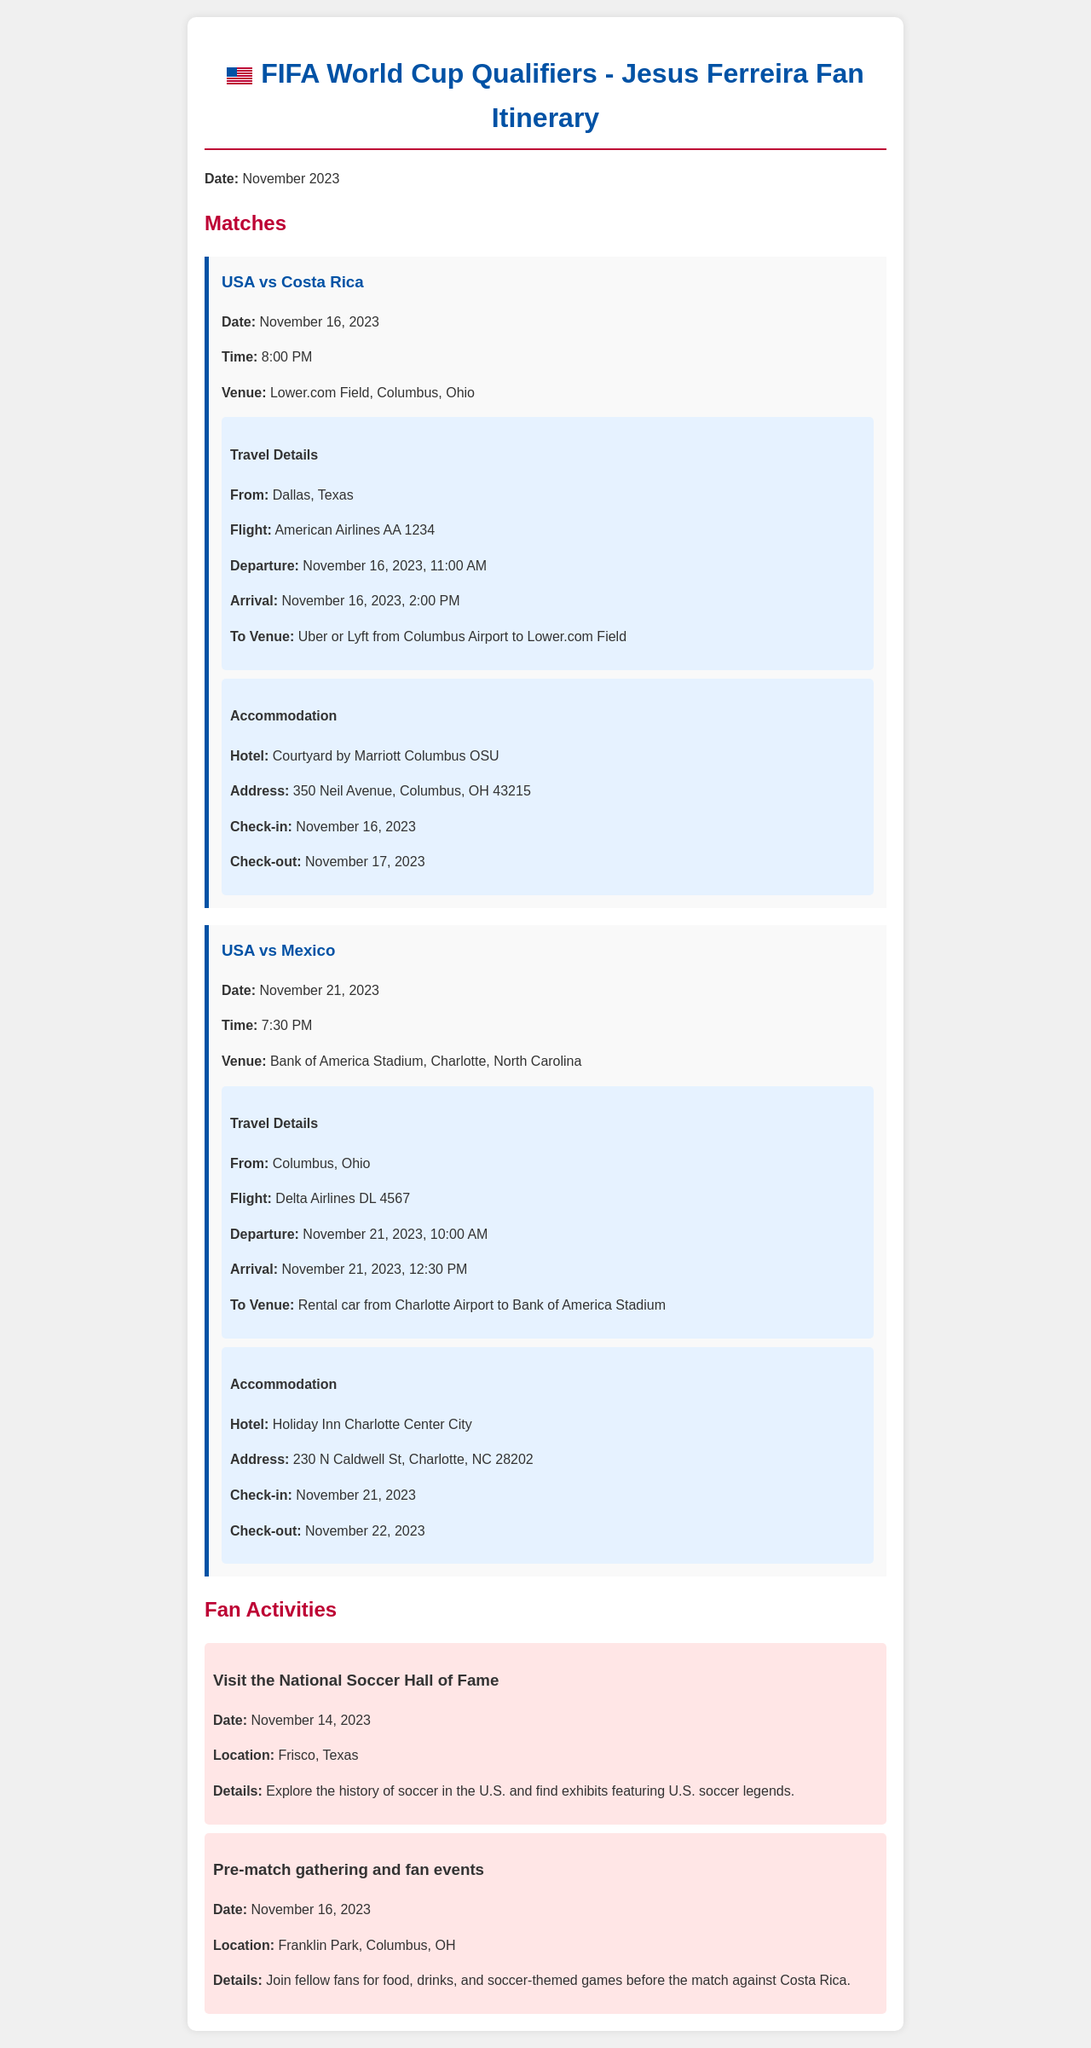What is the date of the match against Costa Rica? The match against Costa Rica is scheduled for November 16, 2023.
Answer: November 16, 2023 What time does the USA vs Mexico match start? The USA vs Mexico match is set to start at 7:30 PM.
Answer: 7:30 PM What is the venue for the match against Costa Rica? The venue for the match against Costa Rica is Lower.com Field, Columbus, Ohio.
Answer: Lower.com Field, Columbus, Ohio Where is the National Soccer Hall of Fame located? The National Soccer Hall of Fame is located in Frisco, Texas.
Answer: Frisco, Texas What is the flight number for the match against Costa Rica? The flight number from Dallas to Columbus for the match is American Airlines AA 1234.
Answer: American Airlines AA 1234 What type of transportation will be taken from Columbus Airport to the venue? The transportation from Columbus Airport to the venue will be Uber or Lyft.
Answer: Uber or Lyft What is the check-out date for the hotel in Charlotte? The check-out date at the Holiday Inn Charlotte Center City is November 22, 2023.
Answer: November 22, 2023 On what date will the pre-match gathering take place? The pre-match gathering will take place on November 16, 2023.
Answer: November 16, 2023 